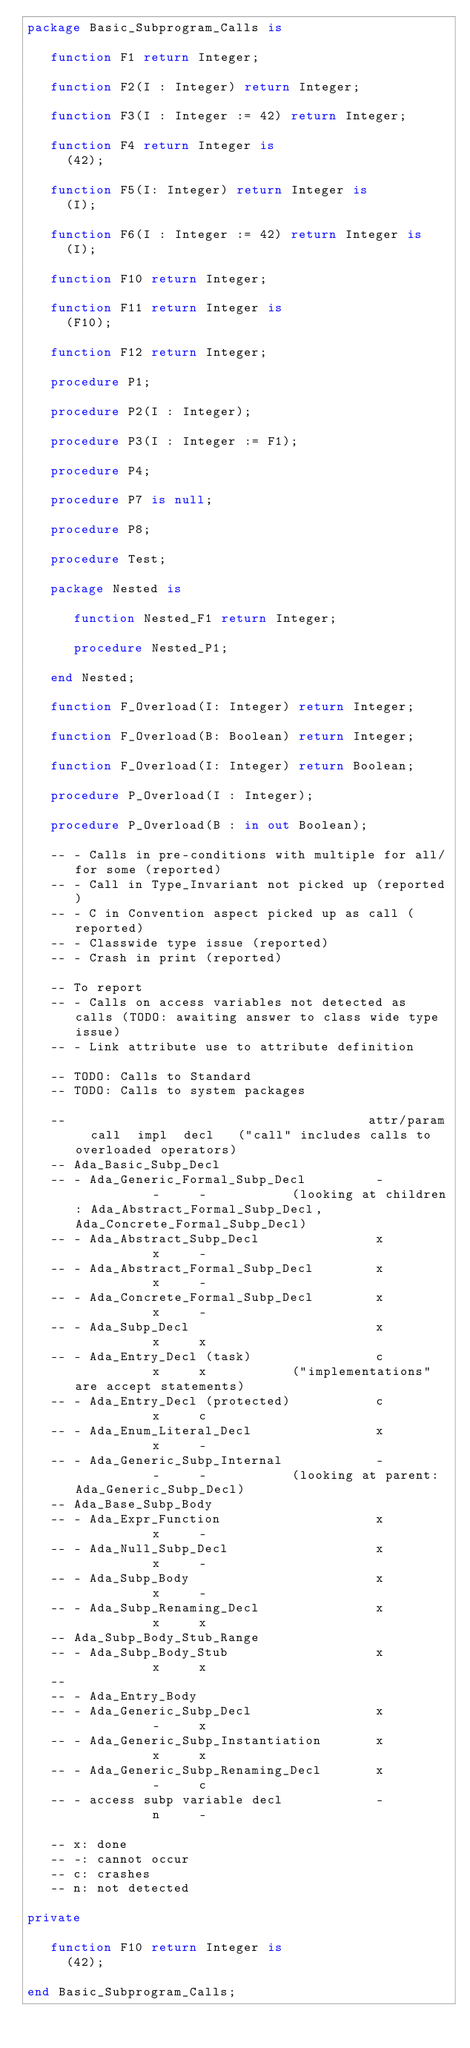<code> <loc_0><loc_0><loc_500><loc_500><_Ada_>package Basic_Subprogram_Calls is

   function F1 return Integer;
   
   function F2(I : Integer) return Integer;
   
   function F3(I : Integer := 42) return Integer;
   
   function F4 return Integer is
     (42);
   
   function F5(I: Integer) return Integer is
     (I);
   
   function F6(I : Integer := 42) return Integer is
     (I);

   function F10 return Integer;

   function F11 return Integer is
     (F10);
   
   function F12 return Integer;
   
   procedure P1;
   
   procedure P2(I : Integer);
   
   procedure P3(I : Integer := F1);
   
   procedure P4;
   
   procedure P7 is null;
   
   procedure P8;
   
   procedure Test;
   
   package Nested is

      function Nested_F1 return Integer;
      
      procedure Nested_P1;

   end Nested;
      
   function F_Overload(I: Integer) return Integer;
   
   function F_Overload(B: Boolean) return Integer;
   
   function F_Overload(I: Integer) return Boolean;

   procedure P_Overload(I : Integer);

   procedure P_Overload(B : in out Boolean);

   -- - Calls in pre-conditions with multiple for all/for some (reported)
   -- - Call in Type_Invariant not picked up (reported)
   -- - C in Convention aspect picked up as call (reported)
   -- - Classwide type issue (reported)
   -- - Crash in print (reported)
   
   -- To report
   -- - Calls on access variables not detected as calls (TODO: awaiting answer to class wide type issue)
   -- - Link attribute use to attribute definition
   
   -- TODO: Calls to Standard
   -- TODO: Calls to system packages
      
   --                                       attr/param  call  impl  decl   ("call" includes calls to overloaded operators)
   -- Ada_Basic_Subp_Decl
   -- - Ada_Generic_Formal_Subp_Decl         -           -     -           (looking at children: Ada_Abstract_Formal_Subp_Decl, Ada_Concrete_Formal_Subp_Decl)
   -- - Ada_Abstract_Subp_Decl               x           x     -
   -- - Ada_Abstract_Formal_Subp_Decl        x           x     -
   -- - Ada_Concrete_Formal_Subp_Decl        x           x     -
   -- - Ada_Subp_Decl                        x           x     x
   -- - Ada_Entry_Decl (task)                c           x     x           ("implementations" are accept statements)
   -- - Ada_Entry_Decl (protected)           c           x     c
   -- - Ada_Enum_Literal_Decl                x           x     -
   -- - Ada_Generic_Subp_Internal            -           -     -           (looking at parent: Ada_Generic_Subp_Decl)
   -- Ada_Base_Subp_Body
   -- - Ada_Expr_Function                    x           x     -
   -- - Ada_Null_Subp_Decl                   x           x     -
   -- - Ada_Subp_Body                        x           x     -
   -- - Ada_Subp_Renaming_Decl               x           x     x
   -- Ada_Subp_Body_Stub_Range
   -- - Ada_Subp_Body_Stub                   x           x     x
   --
   -- - Ada_Entry_Body
   -- - Ada_Generic_Subp_Decl                x           -     x
   -- - Ada_Generic_Subp_Instantiation       x           x     x
   -- - Ada_Generic_Subp_Renaming_Decl       x           -     c
   -- - access subp variable decl            -           n     -

   -- x: done
   -- -: cannot occur
   -- c: crashes
   -- n: not detected
   
private

   function F10 return Integer is
     (42);
   
end Basic_Subprogram_Calls;
</code> 